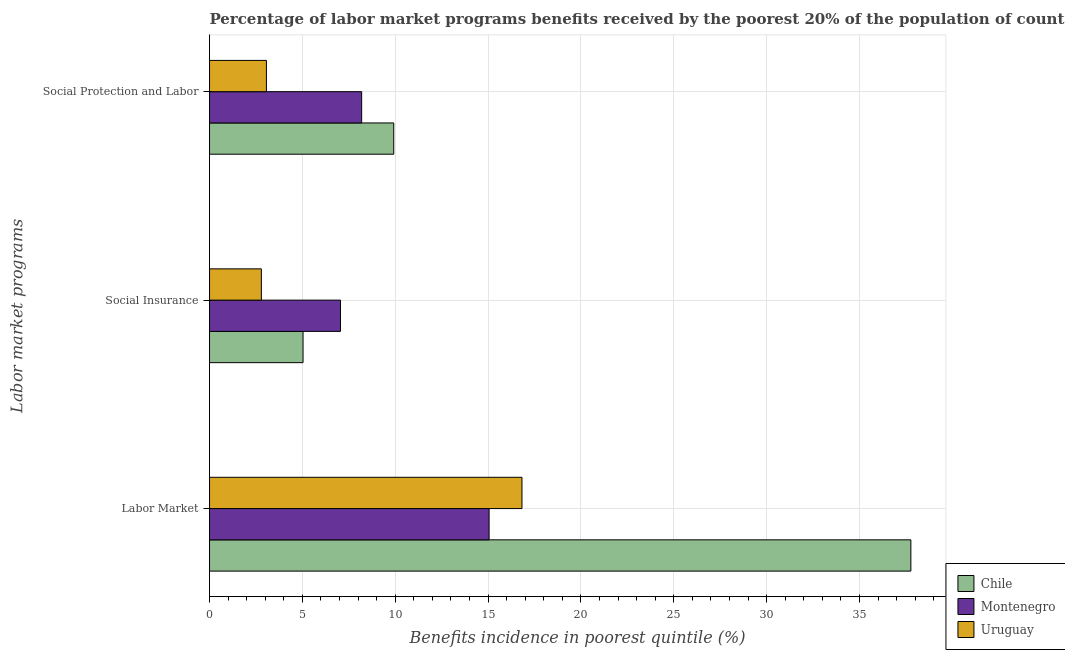How many groups of bars are there?
Your answer should be compact. 3. How many bars are there on the 1st tick from the top?
Your response must be concise. 3. What is the label of the 2nd group of bars from the top?
Offer a terse response. Social Insurance. What is the percentage of benefits received due to social insurance programs in Chile?
Make the answer very short. 5.04. Across all countries, what is the maximum percentage of benefits received due to labor market programs?
Make the answer very short. 37.77. Across all countries, what is the minimum percentage of benefits received due to social protection programs?
Offer a very short reply. 3.06. In which country was the percentage of benefits received due to social protection programs minimum?
Provide a short and direct response. Uruguay. What is the total percentage of benefits received due to social protection programs in the graph?
Offer a very short reply. 21.17. What is the difference between the percentage of benefits received due to social protection programs in Uruguay and that in Montenegro?
Your answer should be compact. -5.13. What is the difference between the percentage of benefits received due to labor market programs in Uruguay and the percentage of benefits received due to social insurance programs in Chile?
Provide a short and direct response. 11.79. What is the average percentage of benefits received due to social insurance programs per country?
Provide a short and direct response. 4.96. What is the difference between the percentage of benefits received due to social protection programs and percentage of benefits received due to social insurance programs in Montenegro?
Your answer should be very brief. 1.14. What is the ratio of the percentage of benefits received due to social insurance programs in Uruguay to that in Montenegro?
Make the answer very short. 0.4. What is the difference between the highest and the second highest percentage of benefits received due to social protection programs?
Your answer should be compact. 1.73. What is the difference between the highest and the lowest percentage of benefits received due to labor market programs?
Your response must be concise. 22.71. What does the 1st bar from the top in Social Insurance represents?
Ensure brevity in your answer.  Uruguay. What does the 2nd bar from the bottom in Social Insurance represents?
Provide a short and direct response. Montenegro. How many countries are there in the graph?
Ensure brevity in your answer.  3. What is the difference between two consecutive major ticks on the X-axis?
Offer a very short reply. 5. Does the graph contain any zero values?
Offer a very short reply. No. Where does the legend appear in the graph?
Make the answer very short. Bottom right. How many legend labels are there?
Give a very brief answer. 3. How are the legend labels stacked?
Your response must be concise. Vertical. What is the title of the graph?
Your response must be concise. Percentage of labor market programs benefits received by the poorest 20% of the population of countries. What is the label or title of the X-axis?
Your answer should be very brief. Benefits incidence in poorest quintile (%). What is the label or title of the Y-axis?
Ensure brevity in your answer.  Labor market programs. What is the Benefits incidence in poorest quintile (%) of Chile in Labor Market?
Your answer should be compact. 37.77. What is the Benefits incidence in poorest quintile (%) of Montenegro in Labor Market?
Keep it short and to the point. 15.05. What is the Benefits incidence in poorest quintile (%) of Uruguay in Labor Market?
Provide a short and direct response. 16.82. What is the Benefits incidence in poorest quintile (%) in Chile in Social Insurance?
Offer a very short reply. 5.04. What is the Benefits incidence in poorest quintile (%) in Montenegro in Social Insurance?
Make the answer very short. 7.05. What is the Benefits incidence in poorest quintile (%) of Uruguay in Social Insurance?
Offer a terse response. 2.79. What is the Benefits incidence in poorest quintile (%) in Chile in Social Protection and Labor?
Make the answer very short. 9.92. What is the Benefits incidence in poorest quintile (%) of Montenegro in Social Protection and Labor?
Your answer should be compact. 8.19. What is the Benefits incidence in poorest quintile (%) of Uruguay in Social Protection and Labor?
Give a very brief answer. 3.06. Across all Labor market programs, what is the maximum Benefits incidence in poorest quintile (%) of Chile?
Provide a succinct answer. 37.77. Across all Labor market programs, what is the maximum Benefits incidence in poorest quintile (%) of Montenegro?
Offer a very short reply. 15.05. Across all Labor market programs, what is the maximum Benefits incidence in poorest quintile (%) in Uruguay?
Offer a terse response. 16.82. Across all Labor market programs, what is the minimum Benefits incidence in poorest quintile (%) of Chile?
Offer a very short reply. 5.04. Across all Labor market programs, what is the minimum Benefits incidence in poorest quintile (%) of Montenegro?
Offer a very short reply. 7.05. Across all Labor market programs, what is the minimum Benefits incidence in poorest quintile (%) in Uruguay?
Ensure brevity in your answer.  2.79. What is the total Benefits incidence in poorest quintile (%) of Chile in the graph?
Keep it short and to the point. 52.72. What is the total Benefits incidence in poorest quintile (%) in Montenegro in the graph?
Give a very brief answer. 30.3. What is the total Benefits incidence in poorest quintile (%) in Uruguay in the graph?
Ensure brevity in your answer.  22.68. What is the difference between the Benefits incidence in poorest quintile (%) of Chile in Labor Market and that in Social Insurance?
Offer a terse response. 32.73. What is the difference between the Benefits incidence in poorest quintile (%) in Montenegro in Labor Market and that in Social Insurance?
Give a very brief answer. 8. What is the difference between the Benefits incidence in poorest quintile (%) in Uruguay in Labor Market and that in Social Insurance?
Provide a succinct answer. 14.03. What is the difference between the Benefits incidence in poorest quintile (%) in Chile in Labor Market and that in Social Protection and Labor?
Give a very brief answer. 27.85. What is the difference between the Benefits incidence in poorest quintile (%) in Montenegro in Labor Market and that in Social Protection and Labor?
Offer a very short reply. 6.86. What is the difference between the Benefits incidence in poorest quintile (%) of Uruguay in Labor Market and that in Social Protection and Labor?
Ensure brevity in your answer.  13.76. What is the difference between the Benefits incidence in poorest quintile (%) of Chile in Social Insurance and that in Social Protection and Labor?
Keep it short and to the point. -4.88. What is the difference between the Benefits incidence in poorest quintile (%) of Montenegro in Social Insurance and that in Social Protection and Labor?
Offer a very short reply. -1.14. What is the difference between the Benefits incidence in poorest quintile (%) of Uruguay in Social Insurance and that in Social Protection and Labor?
Give a very brief answer. -0.27. What is the difference between the Benefits incidence in poorest quintile (%) in Chile in Labor Market and the Benefits incidence in poorest quintile (%) in Montenegro in Social Insurance?
Offer a very short reply. 30.72. What is the difference between the Benefits incidence in poorest quintile (%) of Chile in Labor Market and the Benefits incidence in poorest quintile (%) of Uruguay in Social Insurance?
Offer a very short reply. 34.98. What is the difference between the Benefits incidence in poorest quintile (%) in Montenegro in Labor Market and the Benefits incidence in poorest quintile (%) in Uruguay in Social Insurance?
Make the answer very short. 12.26. What is the difference between the Benefits incidence in poorest quintile (%) of Chile in Labor Market and the Benefits incidence in poorest quintile (%) of Montenegro in Social Protection and Labor?
Provide a short and direct response. 29.58. What is the difference between the Benefits incidence in poorest quintile (%) of Chile in Labor Market and the Benefits incidence in poorest quintile (%) of Uruguay in Social Protection and Labor?
Provide a short and direct response. 34.71. What is the difference between the Benefits incidence in poorest quintile (%) of Montenegro in Labor Market and the Benefits incidence in poorest quintile (%) of Uruguay in Social Protection and Labor?
Offer a terse response. 11.99. What is the difference between the Benefits incidence in poorest quintile (%) of Chile in Social Insurance and the Benefits incidence in poorest quintile (%) of Montenegro in Social Protection and Labor?
Your answer should be compact. -3.16. What is the difference between the Benefits incidence in poorest quintile (%) in Chile in Social Insurance and the Benefits incidence in poorest quintile (%) in Uruguay in Social Protection and Labor?
Offer a terse response. 1.97. What is the difference between the Benefits incidence in poorest quintile (%) in Montenegro in Social Insurance and the Benefits incidence in poorest quintile (%) in Uruguay in Social Protection and Labor?
Your answer should be very brief. 3.99. What is the average Benefits incidence in poorest quintile (%) of Chile per Labor market programs?
Offer a terse response. 17.57. What is the average Benefits incidence in poorest quintile (%) of Montenegro per Labor market programs?
Ensure brevity in your answer.  10.1. What is the average Benefits incidence in poorest quintile (%) of Uruguay per Labor market programs?
Give a very brief answer. 7.56. What is the difference between the Benefits incidence in poorest quintile (%) of Chile and Benefits incidence in poorest quintile (%) of Montenegro in Labor Market?
Provide a succinct answer. 22.71. What is the difference between the Benefits incidence in poorest quintile (%) of Chile and Benefits incidence in poorest quintile (%) of Uruguay in Labor Market?
Keep it short and to the point. 20.94. What is the difference between the Benefits incidence in poorest quintile (%) of Montenegro and Benefits incidence in poorest quintile (%) of Uruguay in Labor Market?
Make the answer very short. -1.77. What is the difference between the Benefits incidence in poorest quintile (%) of Chile and Benefits incidence in poorest quintile (%) of Montenegro in Social Insurance?
Offer a very short reply. -2.02. What is the difference between the Benefits incidence in poorest quintile (%) in Chile and Benefits incidence in poorest quintile (%) in Uruguay in Social Insurance?
Your response must be concise. 2.24. What is the difference between the Benefits incidence in poorest quintile (%) of Montenegro and Benefits incidence in poorest quintile (%) of Uruguay in Social Insurance?
Make the answer very short. 4.26. What is the difference between the Benefits incidence in poorest quintile (%) in Chile and Benefits incidence in poorest quintile (%) in Montenegro in Social Protection and Labor?
Ensure brevity in your answer.  1.73. What is the difference between the Benefits incidence in poorest quintile (%) of Chile and Benefits incidence in poorest quintile (%) of Uruguay in Social Protection and Labor?
Give a very brief answer. 6.86. What is the difference between the Benefits incidence in poorest quintile (%) of Montenegro and Benefits incidence in poorest quintile (%) of Uruguay in Social Protection and Labor?
Offer a terse response. 5.13. What is the ratio of the Benefits incidence in poorest quintile (%) in Chile in Labor Market to that in Social Insurance?
Offer a terse response. 7.5. What is the ratio of the Benefits incidence in poorest quintile (%) in Montenegro in Labor Market to that in Social Insurance?
Your answer should be very brief. 2.13. What is the ratio of the Benefits incidence in poorest quintile (%) in Uruguay in Labor Market to that in Social Insurance?
Make the answer very short. 6.03. What is the ratio of the Benefits incidence in poorest quintile (%) of Chile in Labor Market to that in Social Protection and Labor?
Keep it short and to the point. 3.81. What is the ratio of the Benefits incidence in poorest quintile (%) in Montenegro in Labor Market to that in Social Protection and Labor?
Your answer should be compact. 1.84. What is the ratio of the Benefits incidence in poorest quintile (%) of Uruguay in Labor Market to that in Social Protection and Labor?
Ensure brevity in your answer.  5.49. What is the ratio of the Benefits incidence in poorest quintile (%) in Chile in Social Insurance to that in Social Protection and Labor?
Give a very brief answer. 0.51. What is the ratio of the Benefits incidence in poorest quintile (%) of Montenegro in Social Insurance to that in Social Protection and Labor?
Keep it short and to the point. 0.86. What is the ratio of the Benefits incidence in poorest quintile (%) in Uruguay in Social Insurance to that in Social Protection and Labor?
Make the answer very short. 0.91. What is the difference between the highest and the second highest Benefits incidence in poorest quintile (%) in Chile?
Your answer should be very brief. 27.85. What is the difference between the highest and the second highest Benefits incidence in poorest quintile (%) in Montenegro?
Your response must be concise. 6.86. What is the difference between the highest and the second highest Benefits incidence in poorest quintile (%) of Uruguay?
Make the answer very short. 13.76. What is the difference between the highest and the lowest Benefits incidence in poorest quintile (%) of Chile?
Your response must be concise. 32.73. What is the difference between the highest and the lowest Benefits incidence in poorest quintile (%) in Montenegro?
Keep it short and to the point. 8. What is the difference between the highest and the lowest Benefits incidence in poorest quintile (%) of Uruguay?
Make the answer very short. 14.03. 